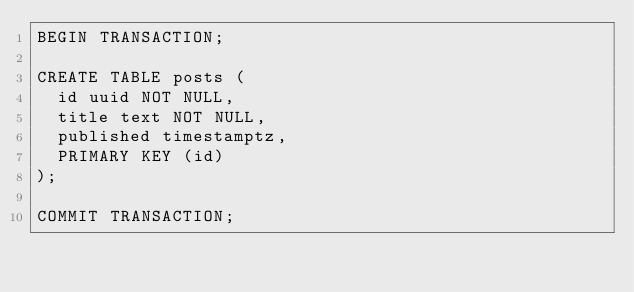Convert code to text. <code><loc_0><loc_0><loc_500><loc_500><_SQL_>BEGIN TRANSACTION;

CREATE TABLE posts (
  id uuid NOT NULL,
  title text NOT NULL,
  published timestamptz,
  PRIMARY KEY (id)
);

COMMIT TRANSACTION;
</code> 